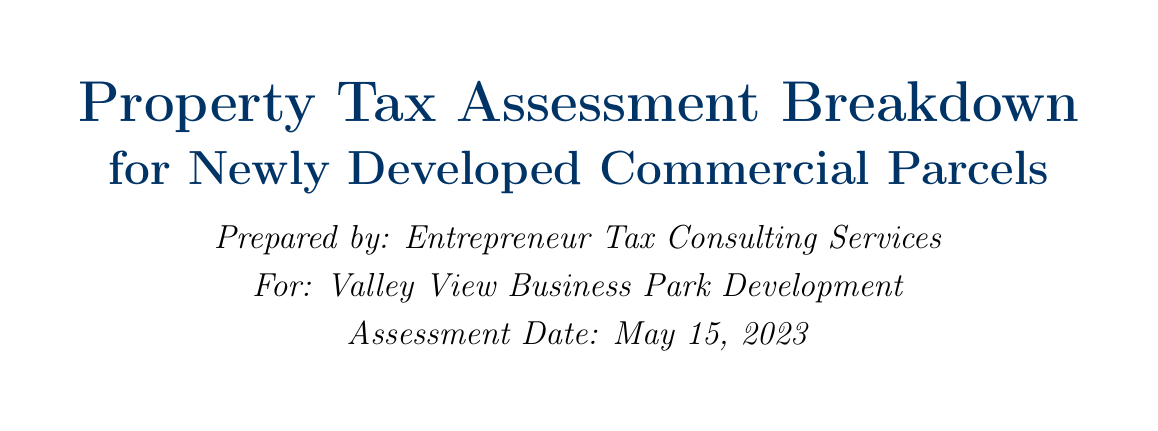what is the total land value? The total land value is mentioned in the document under the Land Value Assessment section.
Answer: $8,578,500 what is the assessed value per square foot of the building? The assessed value per square foot of the building is specified in the Building Value Assessment.
Answer: $225 what is the total assessed value of the property? The total assessed value is calculated and stated in the Total Property Value section.
Answer: $28,878,500 what is the appeal deadline for property tax assessments? The appeal deadline is clearly stated in the Assessment Appeals Process section.
Answer: September 15, 2023 what is the annual property tax amount? The annual property tax amount is provided in the Annual Property Tax Calculation section.
Answer: $1,010,747.50 how much is the Enterprise Zone Tax Credit? The Enterprise Zone Tax Credit details are outlined in the Tax Incentives and Abatements section.
Answer: 50% reduction how many parking spaces are there in the parking lot? The number of parking spaces is mentioned under the Site Improvements section.
Answer: 200 spaces what is the filing fee for an appeal? The filing fee for an appeal is listed in the Assessment Appeals Process section.
Answer: $50 what is the local tax rate as a percentage? The local tax rate is specified in the Tax Rate Calculation section.
Answer: 1.25% 